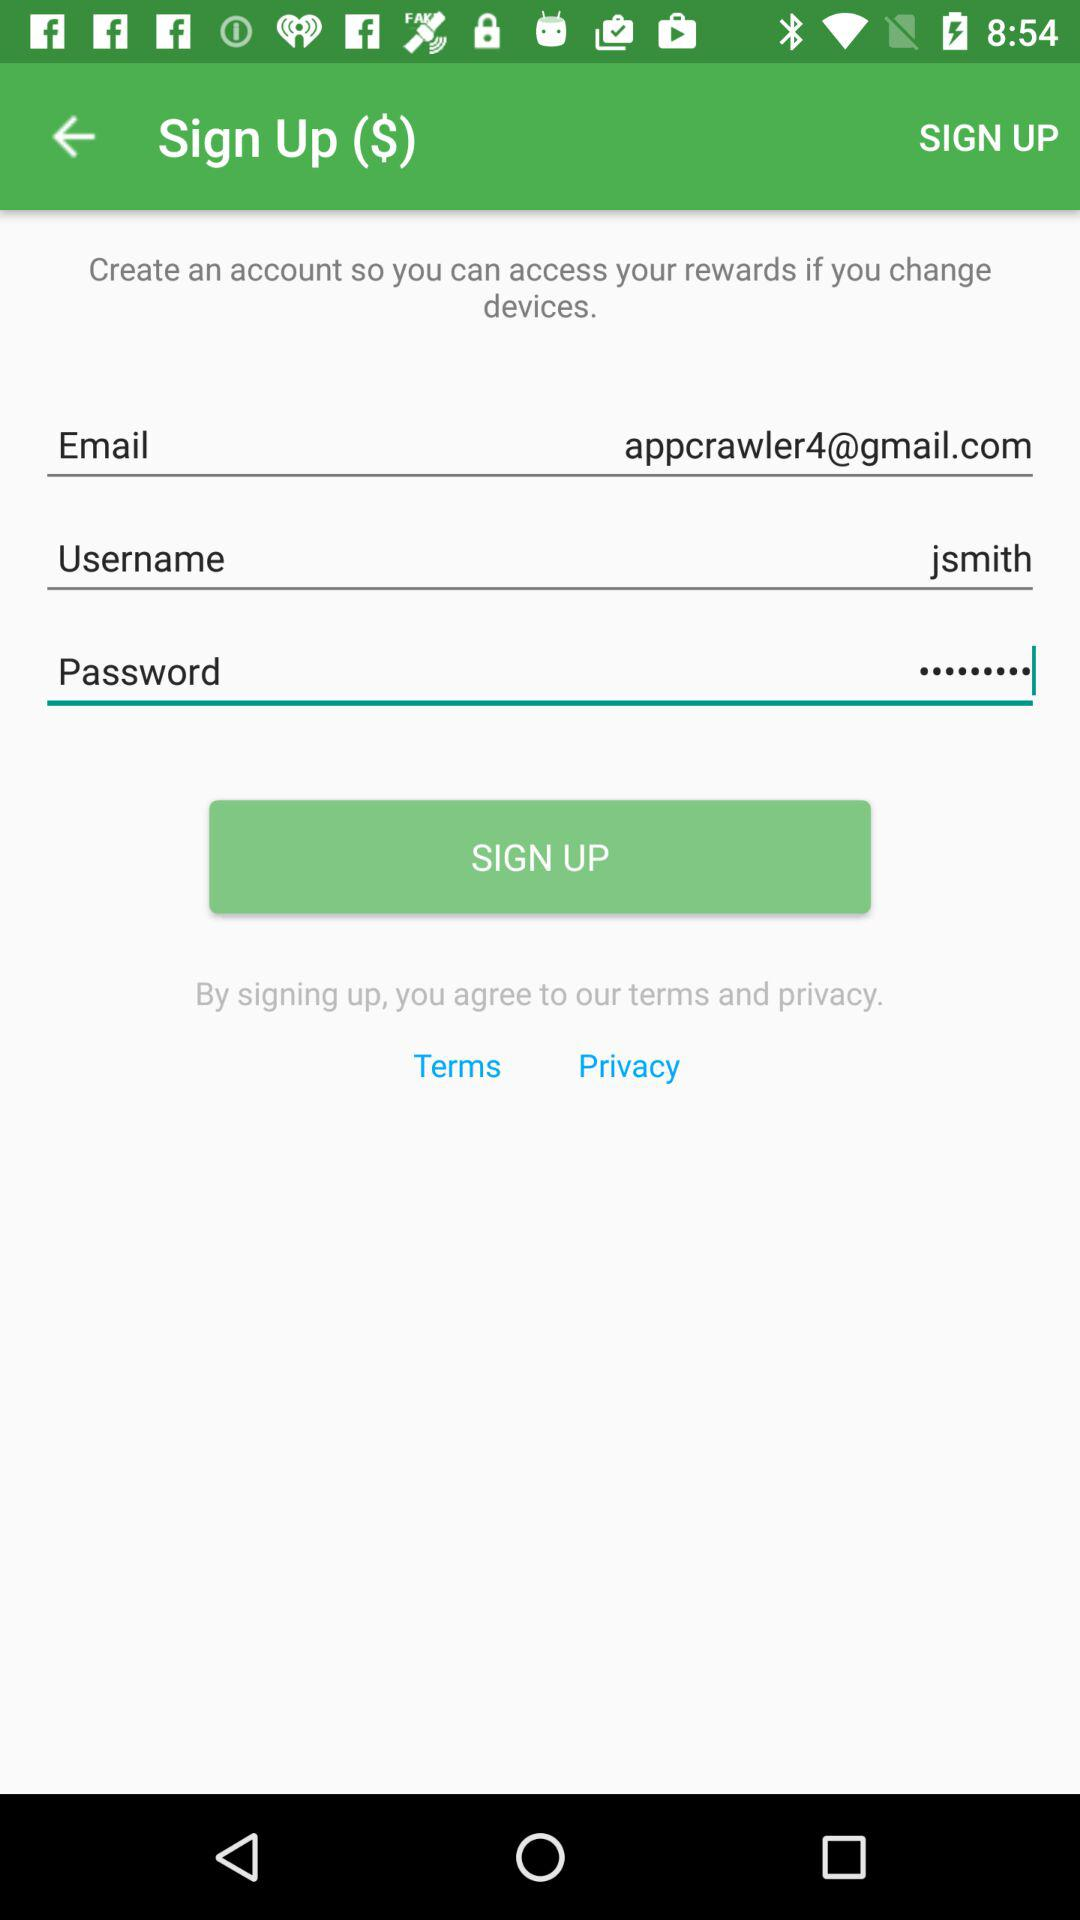How many text inputs are there for personal information?
Answer the question using a single word or phrase. 3 